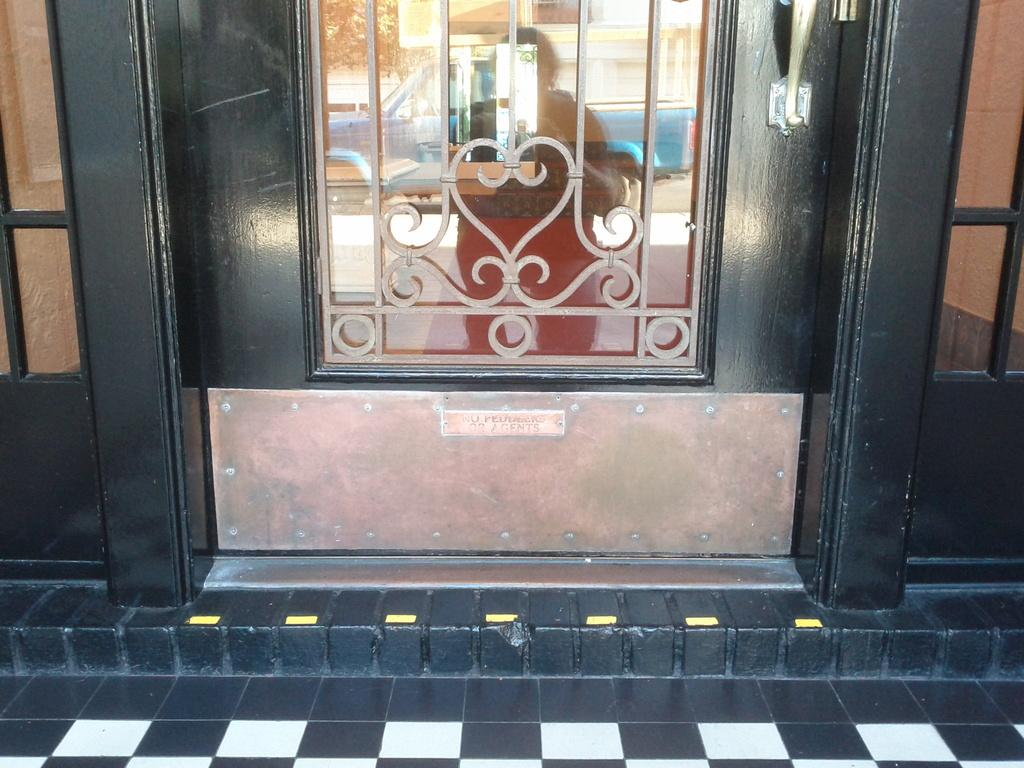What is located in the middle of the image? There is a door in the middle of the image. What can be seen in the image due to reflection? There is a reflected image of a human and a vehicle in the image. What type of vegetable is being used as a seat in the image? There is no vegetable being used as a seat in the image. 